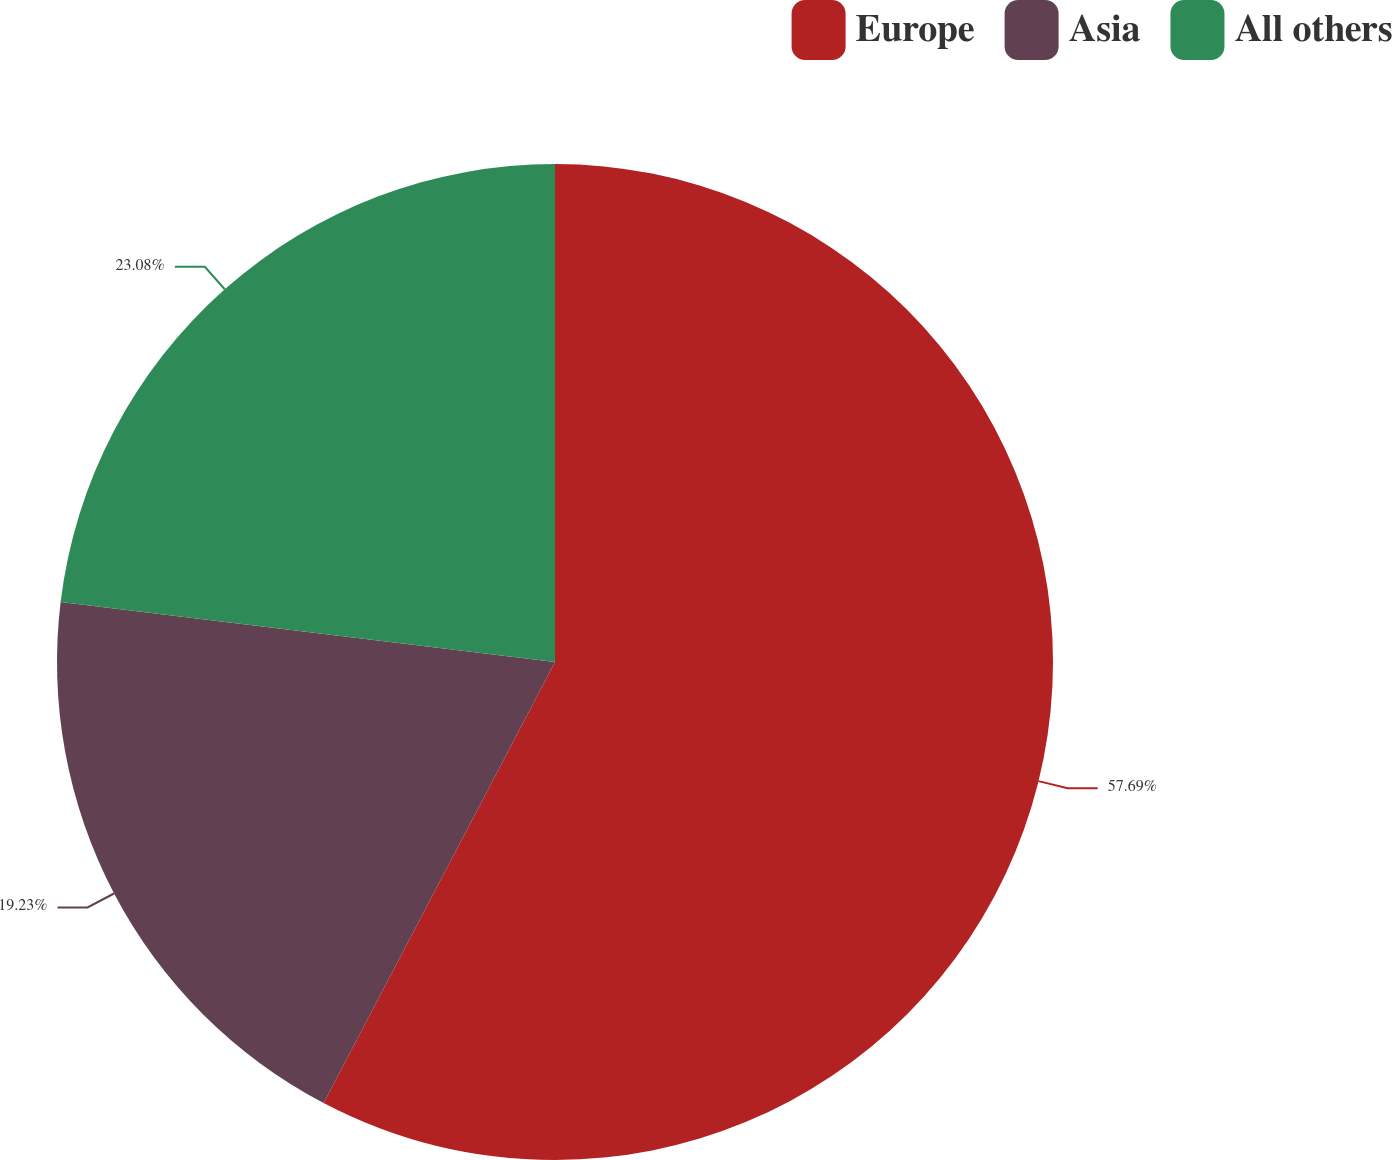Convert chart. <chart><loc_0><loc_0><loc_500><loc_500><pie_chart><fcel>Europe<fcel>Asia<fcel>All others<nl><fcel>57.69%<fcel>19.23%<fcel>23.08%<nl></chart> 